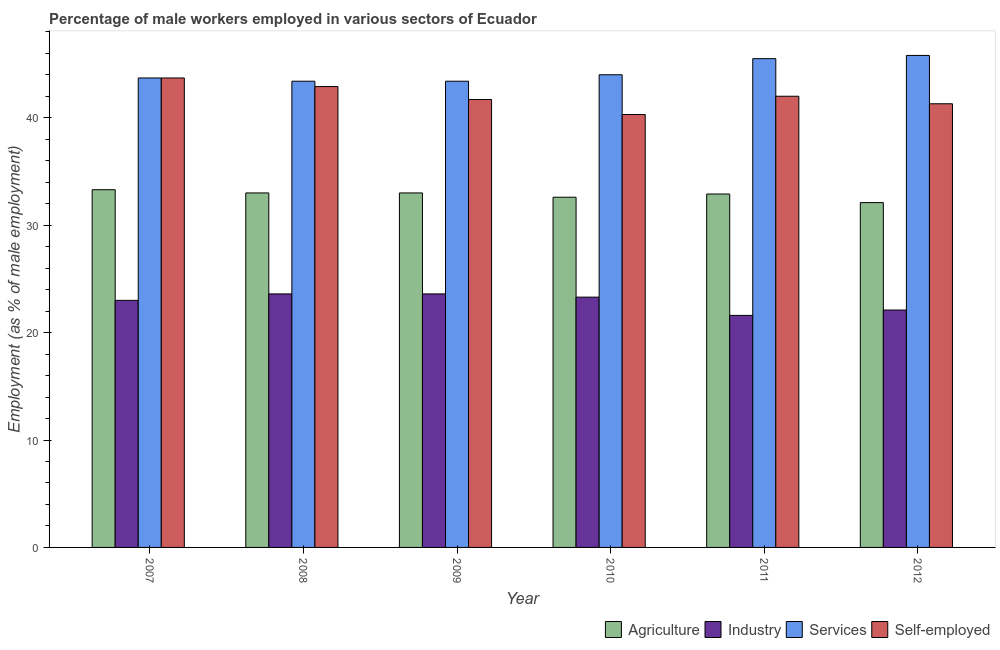How many different coloured bars are there?
Provide a short and direct response. 4. Are the number of bars per tick equal to the number of legend labels?
Keep it short and to the point. Yes. How many bars are there on the 5th tick from the right?
Make the answer very short. 4. In how many cases, is the number of bars for a given year not equal to the number of legend labels?
Your response must be concise. 0. What is the percentage of male workers in industry in 2007?
Provide a succinct answer. 23. Across all years, what is the maximum percentage of male workers in services?
Your answer should be very brief. 45.8. Across all years, what is the minimum percentage of self employed male workers?
Make the answer very short. 40.3. What is the total percentage of male workers in services in the graph?
Provide a succinct answer. 265.8. What is the difference between the percentage of male workers in industry in 2007 and that in 2012?
Make the answer very short. 0.9. What is the difference between the percentage of male workers in services in 2008 and the percentage of self employed male workers in 2009?
Provide a succinct answer. 0. What is the average percentage of male workers in agriculture per year?
Your response must be concise. 32.82. In the year 2009, what is the difference between the percentage of male workers in agriculture and percentage of self employed male workers?
Provide a succinct answer. 0. What is the ratio of the percentage of male workers in agriculture in 2007 to that in 2009?
Keep it short and to the point. 1.01. Is the difference between the percentage of male workers in agriculture in 2007 and 2011 greater than the difference between the percentage of male workers in industry in 2007 and 2011?
Offer a very short reply. No. What is the difference between the highest and the second highest percentage of self employed male workers?
Ensure brevity in your answer.  0.8. What is the difference between the highest and the lowest percentage of male workers in agriculture?
Keep it short and to the point. 1.2. In how many years, is the percentage of self employed male workers greater than the average percentage of self employed male workers taken over all years?
Keep it short and to the point. 3. What does the 3rd bar from the left in 2011 represents?
Your answer should be compact. Services. What does the 2nd bar from the right in 2008 represents?
Offer a very short reply. Services. What is the difference between two consecutive major ticks on the Y-axis?
Give a very brief answer. 10. Where does the legend appear in the graph?
Offer a very short reply. Bottom right. How many legend labels are there?
Your answer should be very brief. 4. What is the title of the graph?
Your response must be concise. Percentage of male workers employed in various sectors of Ecuador. What is the label or title of the X-axis?
Give a very brief answer. Year. What is the label or title of the Y-axis?
Provide a short and direct response. Employment (as % of male employment). What is the Employment (as % of male employment) of Agriculture in 2007?
Offer a very short reply. 33.3. What is the Employment (as % of male employment) in Industry in 2007?
Your answer should be very brief. 23. What is the Employment (as % of male employment) of Services in 2007?
Offer a very short reply. 43.7. What is the Employment (as % of male employment) of Self-employed in 2007?
Provide a short and direct response. 43.7. What is the Employment (as % of male employment) in Agriculture in 2008?
Offer a very short reply. 33. What is the Employment (as % of male employment) in Industry in 2008?
Your response must be concise. 23.6. What is the Employment (as % of male employment) of Services in 2008?
Provide a succinct answer. 43.4. What is the Employment (as % of male employment) in Self-employed in 2008?
Give a very brief answer. 42.9. What is the Employment (as % of male employment) in Agriculture in 2009?
Give a very brief answer. 33. What is the Employment (as % of male employment) of Industry in 2009?
Ensure brevity in your answer.  23.6. What is the Employment (as % of male employment) in Services in 2009?
Provide a short and direct response. 43.4. What is the Employment (as % of male employment) of Self-employed in 2009?
Provide a short and direct response. 41.7. What is the Employment (as % of male employment) of Agriculture in 2010?
Your answer should be very brief. 32.6. What is the Employment (as % of male employment) of Industry in 2010?
Provide a short and direct response. 23.3. What is the Employment (as % of male employment) of Self-employed in 2010?
Provide a succinct answer. 40.3. What is the Employment (as % of male employment) of Agriculture in 2011?
Ensure brevity in your answer.  32.9. What is the Employment (as % of male employment) in Industry in 2011?
Offer a very short reply. 21.6. What is the Employment (as % of male employment) of Services in 2011?
Your answer should be compact. 45.5. What is the Employment (as % of male employment) in Agriculture in 2012?
Offer a terse response. 32.1. What is the Employment (as % of male employment) in Industry in 2012?
Your response must be concise. 22.1. What is the Employment (as % of male employment) of Services in 2012?
Offer a very short reply. 45.8. What is the Employment (as % of male employment) of Self-employed in 2012?
Ensure brevity in your answer.  41.3. Across all years, what is the maximum Employment (as % of male employment) of Agriculture?
Give a very brief answer. 33.3. Across all years, what is the maximum Employment (as % of male employment) of Industry?
Your response must be concise. 23.6. Across all years, what is the maximum Employment (as % of male employment) in Services?
Offer a terse response. 45.8. Across all years, what is the maximum Employment (as % of male employment) in Self-employed?
Your response must be concise. 43.7. Across all years, what is the minimum Employment (as % of male employment) in Agriculture?
Your answer should be very brief. 32.1. Across all years, what is the minimum Employment (as % of male employment) of Industry?
Your answer should be compact. 21.6. Across all years, what is the minimum Employment (as % of male employment) in Services?
Your answer should be compact. 43.4. Across all years, what is the minimum Employment (as % of male employment) in Self-employed?
Offer a very short reply. 40.3. What is the total Employment (as % of male employment) of Agriculture in the graph?
Your answer should be compact. 196.9. What is the total Employment (as % of male employment) of Industry in the graph?
Provide a short and direct response. 137.2. What is the total Employment (as % of male employment) of Services in the graph?
Keep it short and to the point. 265.8. What is the total Employment (as % of male employment) in Self-employed in the graph?
Give a very brief answer. 251.9. What is the difference between the Employment (as % of male employment) of Industry in 2007 and that in 2008?
Offer a very short reply. -0.6. What is the difference between the Employment (as % of male employment) in Industry in 2007 and that in 2009?
Ensure brevity in your answer.  -0.6. What is the difference between the Employment (as % of male employment) in Services in 2007 and that in 2009?
Offer a very short reply. 0.3. What is the difference between the Employment (as % of male employment) in Services in 2007 and that in 2010?
Give a very brief answer. -0.3. What is the difference between the Employment (as % of male employment) of Self-employed in 2007 and that in 2010?
Keep it short and to the point. 3.4. What is the difference between the Employment (as % of male employment) of Industry in 2007 and that in 2011?
Provide a short and direct response. 1.4. What is the difference between the Employment (as % of male employment) of Services in 2007 and that in 2011?
Keep it short and to the point. -1.8. What is the difference between the Employment (as % of male employment) of Self-employed in 2007 and that in 2011?
Make the answer very short. 1.7. What is the difference between the Employment (as % of male employment) of Self-employed in 2007 and that in 2012?
Keep it short and to the point. 2.4. What is the difference between the Employment (as % of male employment) of Agriculture in 2008 and that in 2009?
Provide a short and direct response. 0. What is the difference between the Employment (as % of male employment) in Self-employed in 2008 and that in 2009?
Make the answer very short. 1.2. What is the difference between the Employment (as % of male employment) in Agriculture in 2008 and that in 2010?
Your response must be concise. 0.4. What is the difference between the Employment (as % of male employment) of Industry in 2008 and that in 2010?
Provide a short and direct response. 0.3. What is the difference between the Employment (as % of male employment) of Services in 2008 and that in 2010?
Keep it short and to the point. -0.6. What is the difference between the Employment (as % of male employment) in Industry in 2008 and that in 2011?
Your response must be concise. 2. What is the difference between the Employment (as % of male employment) in Services in 2008 and that in 2011?
Offer a very short reply. -2.1. What is the difference between the Employment (as % of male employment) of Agriculture in 2008 and that in 2012?
Make the answer very short. 0.9. What is the difference between the Employment (as % of male employment) of Industry in 2008 and that in 2012?
Ensure brevity in your answer.  1.5. What is the difference between the Employment (as % of male employment) in Agriculture in 2009 and that in 2010?
Provide a short and direct response. 0.4. What is the difference between the Employment (as % of male employment) of Industry in 2009 and that in 2010?
Provide a short and direct response. 0.3. What is the difference between the Employment (as % of male employment) of Self-employed in 2009 and that in 2010?
Provide a short and direct response. 1.4. What is the difference between the Employment (as % of male employment) in Agriculture in 2009 and that in 2011?
Offer a terse response. 0.1. What is the difference between the Employment (as % of male employment) in Industry in 2009 and that in 2011?
Give a very brief answer. 2. What is the difference between the Employment (as % of male employment) of Services in 2009 and that in 2011?
Your answer should be very brief. -2.1. What is the difference between the Employment (as % of male employment) of Agriculture in 2009 and that in 2012?
Offer a terse response. 0.9. What is the difference between the Employment (as % of male employment) of Industry in 2009 and that in 2012?
Ensure brevity in your answer.  1.5. What is the difference between the Employment (as % of male employment) in Services in 2009 and that in 2012?
Offer a very short reply. -2.4. What is the difference between the Employment (as % of male employment) of Self-employed in 2009 and that in 2012?
Provide a short and direct response. 0.4. What is the difference between the Employment (as % of male employment) in Industry in 2010 and that in 2011?
Make the answer very short. 1.7. What is the difference between the Employment (as % of male employment) in Self-employed in 2010 and that in 2011?
Give a very brief answer. -1.7. What is the difference between the Employment (as % of male employment) in Industry in 2011 and that in 2012?
Your response must be concise. -0.5. What is the difference between the Employment (as % of male employment) of Agriculture in 2007 and the Employment (as % of male employment) of Industry in 2008?
Provide a short and direct response. 9.7. What is the difference between the Employment (as % of male employment) of Agriculture in 2007 and the Employment (as % of male employment) of Services in 2008?
Your response must be concise. -10.1. What is the difference between the Employment (as % of male employment) in Agriculture in 2007 and the Employment (as % of male employment) in Self-employed in 2008?
Give a very brief answer. -9.6. What is the difference between the Employment (as % of male employment) of Industry in 2007 and the Employment (as % of male employment) of Services in 2008?
Your answer should be compact. -20.4. What is the difference between the Employment (as % of male employment) of Industry in 2007 and the Employment (as % of male employment) of Self-employed in 2008?
Provide a succinct answer. -19.9. What is the difference between the Employment (as % of male employment) of Agriculture in 2007 and the Employment (as % of male employment) of Industry in 2009?
Your answer should be compact. 9.7. What is the difference between the Employment (as % of male employment) of Agriculture in 2007 and the Employment (as % of male employment) of Services in 2009?
Ensure brevity in your answer.  -10.1. What is the difference between the Employment (as % of male employment) in Industry in 2007 and the Employment (as % of male employment) in Services in 2009?
Give a very brief answer. -20.4. What is the difference between the Employment (as % of male employment) of Industry in 2007 and the Employment (as % of male employment) of Self-employed in 2009?
Offer a terse response. -18.7. What is the difference between the Employment (as % of male employment) in Services in 2007 and the Employment (as % of male employment) in Self-employed in 2009?
Keep it short and to the point. 2. What is the difference between the Employment (as % of male employment) in Agriculture in 2007 and the Employment (as % of male employment) in Services in 2010?
Your answer should be compact. -10.7. What is the difference between the Employment (as % of male employment) of Industry in 2007 and the Employment (as % of male employment) of Services in 2010?
Offer a very short reply. -21. What is the difference between the Employment (as % of male employment) in Industry in 2007 and the Employment (as % of male employment) in Self-employed in 2010?
Your answer should be compact. -17.3. What is the difference between the Employment (as % of male employment) in Agriculture in 2007 and the Employment (as % of male employment) in Services in 2011?
Offer a very short reply. -12.2. What is the difference between the Employment (as % of male employment) in Industry in 2007 and the Employment (as % of male employment) in Services in 2011?
Offer a terse response. -22.5. What is the difference between the Employment (as % of male employment) of Agriculture in 2007 and the Employment (as % of male employment) of Self-employed in 2012?
Offer a very short reply. -8. What is the difference between the Employment (as % of male employment) in Industry in 2007 and the Employment (as % of male employment) in Services in 2012?
Provide a short and direct response. -22.8. What is the difference between the Employment (as % of male employment) in Industry in 2007 and the Employment (as % of male employment) in Self-employed in 2012?
Give a very brief answer. -18.3. What is the difference between the Employment (as % of male employment) of Agriculture in 2008 and the Employment (as % of male employment) of Industry in 2009?
Provide a short and direct response. 9.4. What is the difference between the Employment (as % of male employment) in Agriculture in 2008 and the Employment (as % of male employment) in Services in 2009?
Your answer should be very brief. -10.4. What is the difference between the Employment (as % of male employment) of Agriculture in 2008 and the Employment (as % of male employment) of Self-employed in 2009?
Ensure brevity in your answer.  -8.7. What is the difference between the Employment (as % of male employment) of Industry in 2008 and the Employment (as % of male employment) of Services in 2009?
Your answer should be very brief. -19.8. What is the difference between the Employment (as % of male employment) in Industry in 2008 and the Employment (as % of male employment) in Self-employed in 2009?
Ensure brevity in your answer.  -18.1. What is the difference between the Employment (as % of male employment) in Agriculture in 2008 and the Employment (as % of male employment) in Services in 2010?
Ensure brevity in your answer.  -11. What is the difference between the Employment (as % of male employment) in Agriculture in 2008 and the Employment (as % of male employment) in Self-employed in 2010?
Offer a very short reply. -7.3. What is the difference between the Employment (as % of male employment) in Industry in 2008 and the Employment (as % of male employment) in Services in 2010?
Your response must be concise. -20.4. What is the difference between the Employment (as % of male employment) of Industry in 2008 and the Employment (as % of male employment) of Self-employed in 2010?
Ensure brevity in your answer.  -16.7. What is the difference between the Employment (as % of male employment) in Services in 2008 and the Employment (as % of male employment) in Self-employed in 2010?
Give a very brief answer. 3.1. What is the difference between the Employment (as % of male employment) of Agriculture in 2008 and the Employment (as % of male employment) of Services in 2011?
Ensure brevity in your answer.  -12.5. What is the difference between the Employment (as % of male employment) in Industry in 2008 and the Employment (as % of male employment) in Services in 2011?
Offer a terse response. -21.9. What is the difference between the Employment (as % of male employment) of Industry in 2008 and the Employment (as % of male employment) of Self-employed in 2011?
Your answer should be very brief. -18.4. What is the difference between the Employment (as % of male employment) of Services in 2008 and the Employment (as % of male employment) of Self-employed in 2011?
Your answer should be compact. 1.4. What is the difference between the Employment (as % of male employment) in Agriculture in 2008 and the Employment (as % of male employment) in Industry in 2012?
Ensure brevity in your answer.  10.9. What is the difference between the Employment (as % of male employment) of Agriculture in 2008 and the Employment (as % of male employment) of Services in 2012?
Offer a very short reply. -12.8. What is the difference between the Employment (as % of male employment) of Agriculture in 2008 and the Employment (as % of male employment) of Self-employed in 2012?
Your answer should be compact. -8.3. What is the difference between the Employment (as % of male employment) in Industry in 2008 and the Employment (as % of male employment) in Services in 2012?
Give a very brief answer. -22.2. What is the difference between the Employment (as % of male employment) of Industry in 2008 and the Employment (as % of male employment) of Self-employed in 2012?
Offer a terse response. -17.7. What is the difference between the Employment (as % of male employment) in Agriculture in 2009 and the Employment (as % of male employment) in Services in 2010?
Provide a succinct answer. -11. What is the difference between the Employment (as % of male employment) of Industry in 2009 and the Employment (as % of male employment) of Services in 2010?
Provide a short and direct response. -20.4. What is the difference between the Employment (as % of male employment) in Industry in 2009 and the Employment (as % of male employment) in Self-employed in 2010?
Your answer should be compact. -16.7. What is the difference between the Employment (as % of male employment) of Services in 2009 and the Employment (as % of male employment) of Self-employed in 2010?
Keep it short and to the point. 3.1. What is the difference between the Employment (as % of male employment) in Agriculture in 2009 and the Employment (as % of male employment) in Industry in 2011?
Give a very brief answer. 11.4. What is the difference between the Employment (as % of male employment) of Agriculture in 2009 and the Employment (as % of male employment) of Services in 2011?
Keep it short and to the point. -12.5. What is the difference between the Employment (as % of male employment) in Agriculture in 2009 and the Employment (as % of male employment) in Self-employed in 2011?
Give a very brief answer. -9. What is the difference between the Employment (as % of male employment) in Industry in 2009 and the Employment (as % of male employment) in Services in 2011?
Your answer should be compact. -21.9. What is the difference between the Employment (as % of male employment) of Industry in 2009 and the Employment (as % of male employment) of Self-employed in 2011?
Keep it short and to the point. -18.4. What is the difference between the Employment (as % of male employment) of Agriculture in 2009 and the Employment (as % of male employment) of Self-employed in 2012?
Keep it short and to the point. -8.3. What is the difference between the Employment (as % of male employment) of Industry in 2009 and the Employment (as % of male employment) of Services in 2012?
Your response must be concise. -22.2. What is the difference between the Employment (as % of male employment) in Industry in 2009 and the Employment (as % of male employment) in Self-employed in 2012?
Offer a very short reply. -17.7. What is the difference between the Employment (as % of male employment) in Services in 2009 and the Employment (as % of male employment) in Self-employed in 2012?
Ensure brevity in your answer.  2.1. What is the difference between the Employment (as % of male employment) in Agriculture in 2010 and the Employment (as % of male employment) in Services in 2011?
Offer a very short reply. -12.9. What is the difference between the Employment (as % of male employment) of Agriculture in 2010 and the Employment (as % of male employment) of Self-employed in 2011?
Ensure brevity in your answer.  -9.4. What is the difference between the Employment (as % of male employment) in Industry in 2010 and the Employment (as % of male employment) in Services in 2011?
Make the answer very short. -22.2. What is the difference between the Employment (as % of male employment) in Industry in 2010 and the Employment (as % of male employment) in Self-employed in 2011?
Offer a very short reply. -18.7. What is the difference between the Employment (as % of male employment) in Agriculture in 2010 and the Employment (as % of male employment) in Services in 2012?
Provide a succinct answer. -13.2. What is the difference between the Employment (as % of male employment) in Industry in 2010 and the Employment (as % of male employment) in Services in 2012?
Your response must be concise. -22.5. What is the difference between the Employment (as % of male employment) in Services in 2010 and the Employment (as % of male employment) in Self-employed in 2012?
Provide a short and direct response. 2.7. What is the difference between the Employment (as % of male employment) in Industry in 2011 and the Employment (as % of male employment) in Services in 2012?
Offer a terse response. -24.2. What is the difference between the Employment (as % of male employment) of Industry in 2011 and the Employment (as % of male employment) of Self-employed in 2012?
Your response must be concise. -19.7. What is the average Employment (as % of male employment) of Agriculture per year?
Keep it short and to the point. 32.82. What is the average Employment (as % of male employment) of Industry per year?
Provide a short and direct response. 22.87. What is the average Employment (as % of male employment) of Services per year?
Give a very brief answer. 44.3. What is the average Employment (as % of male employment) in Self-employed per year?
Provide a short and direct response. 41.98. In the year 2007, what is the difference between the Employment (as % of male employment) in Industry and Employment (as % of male employment) in Services?
Provide a short and direct response. -20.7. In the year 2007, what is the difference between the Employment (as % of male employment) in Industry and Employment (as % of male employment) in Self-employed?
Offer a terse response. -20.7. In the year 2008, what is the difference between the Employment (as % of male employment) of Agriculture and Employment (as % of male employment) of Self-employed?
Keep it short and to the point. -9.9. In the year 2008, what is the difference between the Employment (as % of male employment) of Industry and Employment (as % of male employment) of Services?
Offer a very short reply. -19.8. In the year 2008, what is the difference between the Employment (as % of male employment) of Industry and Employment (as % of male employment) of Self-employed?
Give a very brief answer. -19.3. In the year 2008, what is the difference between the Employment (as % of male employment) of Services and Employment (as % of male employment) of Self-employed?
Your response must be concise. 0.5. In the year 2009, what is the difference between the Employment (as % of male employment) in Agriculture and Employment (as % of male employment) in Services?
Ensure brevity in your answer.  -10.4. In the year 2009, what is the difference between the Employment (as % of male employment) of Industry and Employment (as % of male employment) of Services?
Ensure brevity in your answer.  -19.8. In the year 2009, what is the difference between the Employment (as % of male employment) of Industry and Employment (as % of male employment) of Self-employed?
Offer a terse response. -18.1. In the year 2009, what is the difference between the Employment (as % of male employment) in Services and Employment (as % of male employment) in Self-employed?
Keep it short and to the point. 1.7. In the year 2010, what is the difference between the Employment (as % of male employment) in Agriculture and Employment (as % of male employment) in Self-employed?
Make the answer very short. -7.7. In the year 2010, what is the difference between the Employment (as % of male employment) in Industry and Employment (as % of male employment) in Services?
Your answer should be very brief. -20.7. In the year 2010, what is the difference between the Employment (as % of male employment) of Industry and Employment (as % of male employment) of Self-employed?
Keep it short and to the point. -17. In the year 2011, what is the difference between the Employment (as % of male employment) of Agriculture and Employment (as % of male employment) of Self-employed?
Give a very brief answer. -9.1. In the year 2011, what is the difference between the Employment (as % of male employment) of Industry and Employment (as % of male employment) of Services?
Ensure brevity in your answer.  -23.9. In the year 2011, what is the difference between the Employment (as % of male employment) of Industry and Employment (as % of male employment) of Self-employed?
Provide a succinct answer. -20.4. In the year 2011, what is the difference between the Employment (as % of male employment) in Services and Employment (as % of male employment) in Self-employed?
Give a very brief answer. 3.5. In the year 2012, what is the difference between the Employment (as % of male employment) of Agriculture and Employment (as % of male employment) of Services?
Your answer should be compact. -13.7. In the year 2012, what is the difference between the Employment (as % of male employment) in Industry and Employment (as % of male employment) in Services?
Your answer should be very brief. -23.7. In the year 2012, what is the difference between the Employment (as % of male employment) in Industry and Employment (as % of male employment) in Self-employed?
Your answer should be very brief. -19.2. In the year 2012, what is the difference between the Employment (as % of male employment) of Services and Employment (as % of male employment) of Self-employed?
Provide a succinct answer. 4.5. What is the ratio of the Employment (as % of male employment) of Agriculture in 2007 to that in 2008?
Your answer should be very brief. 1.01. What is the ratio of the Employment (as % of male employment) of Industry in 2007 to that in 2008?
Offer a terse response. 0.97. What is the ratio of the Employment (as % of male employment) in Self-employed in 2007 to that in 2008?
Offer a very short reply. 1.02. What is the ratio of the Employment (as % of male employment) of Agriculture in 2007 to that in 2009?
Keep it short and to the point. 1.01. What is the ratio of the Employment (as % of male employment) in Industry in 2007 to that in 2009?
Provide a succinct answer. 0.97. What is the ratio of the Employment (as % of male employment) of Self-employed in 2007 to that in 2009?
Make the answer very short. 1.05. What is the ratio of the Employment (as % of male employment) in Agriculture in 2007 to that in 2010?
Your answer should be very brief. 1.02. What is the ratio of the Employment (as % of male employment) in Industry in 2007 to that in 2010?
Provide a short and direct response. 0.99. What is the ratio of the Employment (as % of male employment) of Services in 2007 to that in 2010?
Keep it short and to the point. 0.99. What is the ratio of the Employment (as % of male employment) in Self-employed in 2007 to that in 2010?
Offer a terse response. 1.08. What is the ratio of the Employment (as % of male employment) of Agriculture in 2007 to that in 2011?
Make the answer very short. 1.01. What is the ratio of the Employment (as % of male employment) in Industry in 2007 to that in 2011?
Keep it short and to the point. 1.06. What is the ratio of the Employment (as % of male employment) in Services in 2007 to that in 2011?
Your response must be concise. 0.96. What is the ratio of the Employment (as % of male employment) of Self-employed in 2007 to that in 2011?
Provide a short and direct response. 1.04. What is the ratio of the Employment (as % of male employment) in Agriculture in 2007 to that in 2012?
Provide a succinct answer. 1.04. What is the ratio of the Employment (as % of male employment) in Industry in 2007 to that in 2012?
Offer a terse response. 1.04. What is the ratio of the Employment (as % of male employment) in Services in 2007 to that in 2012?
Give a very brief answer. 0.95. What is the ratio of the Employment (as % of male employment) in Self-employed in 2007 to that in 2012?
Provide a short and direct response. 1.06. What is the ratio of the Employment (as % of male employment) in Agriculture in 2008 to that in 2009?
Offer a very short reply. 1. What is the ratio of the Employment (as % of male employment) of Self-employed in 2008 to that in 2009?
Offer a terse response. 1.03. What is the ratio of the Employment (as % of male employment) of Agriculture in 2008 to that in 2010?
Your answer should be compact. 1.01. What is the ratio of the Employment (as % of male employment) in Industry in 2008 to that in 2010?
Your answer should be very brief. 1.01. What is the ratio of the Employment (as % of male employment) of Services in 2008 to that in 2010?
Your answer should be compact. 0.99. What is the ratio of the Employment (as % of male employment) in Self-employed in 2008 to that in 2010?
Provide a succinct answer. 1.06. What is the ratio of the Employment (as % of male employment) in Industry in 2008 to that in 2011?
Keep it short and to the point. 1.09. What is the ratio of the Employment (as % of male employment) of Services in 2008 to that in 2011?
Ensure brevity in your answer.  0.95. What is the ratio of the Employment (as % of male employment) in Self-employed in 2008 to that in 2011?
Provide a short and direct response. 1.02. What is the ratio of the Employment (as % of male employment) of Agriculture in 2008 to that in 2012?
Provide a succinct answer. 1.03. What is the ratio of the Employment (as % of male employment) in Industry in 2008 to that in 2012?
Your answer should be very brief. 1.07. What is the ratio of the Employment (as % of male employment) of Services in 2008 to that in 2012?
Give a very brief answer. 0.95. What is the ratio of the Employment (as % of male employment) in Self-employed in 2008 to that in 2012?
Ensure brevity in your answer.  1.04. What is the ratio of the Employment (as % of male employment) of Agriculture in 2009 to that in 2010?
Your answer should be compact. 1.01. What is the ratio of the Employment (as % of male employment) of Industry in 2009 to that in 2010?
Your answer should be very brief. 1.01. What is the ratio of the Employment (as % of male employment) of Services in 2009 to that in 2010?
Give a very brief answer. 0.99. What is the ratio of the Employment (as % of male employment) of Self-employed in 2009 to that in 2010?
Make the answer very short. 1.03. What is the ratio of the Employment (as % of male employment) of Agriculture in 2009 to that in 2011?
Your answer should be very brief. 1. What is the ratio of the Employment (as % of male employment) of Industry in 2009 to that in 2011?
Your answer should be very brief. 1.09. What is the ratio of the Employment (as % of male employment) in Services in 2009 to that in 2011?
Ensure brevity in your answer.  0.95. What is the ratio of the Employment (as % of male employment) of Self-employed in 2009 to that in 2011?
Make the answer very short. 0.99. What is the ratio of the Employment (as % of male employment) in Agriculture in 2009 to that in 2012?
Your answer should be compact. 1.03. What is the ratio of the Employment (as % of male employment) of Industry in 2009 to that in 2012?
Ensure brevity in your answer.  1.07. What is the ratio of the Employment (as % of male employment) in Services in 2009 to that in 2012?
Ensure brevity in your answer.  0.95. What is the ratio of the Employment (as % of male employment) of Self-employed in 2009 to that in 2012?
Provide a short and direct response. 1.01. What is the ratio of the Employment (as % of male employment) of Agriculture in 2010 to that in 2011?
Provide a succinct answer. 0.99. What is the ratio of the Employment (as % of male employment) of Industry in 2010 to that in 2011?
Keep it short and to the point. 1.08. What is the ratio of the Employment (as % of male employment) of Self-employed in 2010 to that in 2011?
Provide a succinct answer. 0.96. What is the ratio of the Employment (as % of male employment) of Agriculture in 2010 to that in 2012?
Provide a short and direct response. 1.02. What is the ratio of the Employment (as % of male employment) in Industry in 2010 to that in 2012?
Provide a short and direct response. 1.05. What is the ratio of the Employment (as % of male employment) of Services in 2010 to that in 2012?
Keep it short and to the point. 0.96. What is the ratio of the Employment (as % of male employment) of Self-employed in 2010 to that in 2012?
Offer a very short reply. 0.98. What is the ratio of the Employment (as % of male employment) of Agriculture in 2011 to that in 2012?
Make the answer very short. 1.02. What is the ratio of the Employment (as % of male employment) of Industry in 2011 to that in 2012?
Make the answer very short. 0.98. What is the ratio of the Employment (as % of male employment) in Services in 2011 to that in 2012?
Your response must be concise. 0.99. What is the ratio of the Employment (as % of male employment) in Self-employed in 2011 to that in 2012?
Your answer should be very brief. 1.02. What is the difference between the highest and the second highest Employment (as % of male employment) of Agriculture?
Offer a terse response. 0.3. What is the difference between the highest and the second highest Employment (as % of male employment) in Industry?
Keep it short and to the point. 0. What is the difference between the highest and the lowest Employment (as % of male employment) in Industry?
Offer a very short reply. 2. What is the difference between the highest and the lowest Employment (as % of male employment) of Services?
Your answer should be compact. 2.4. 